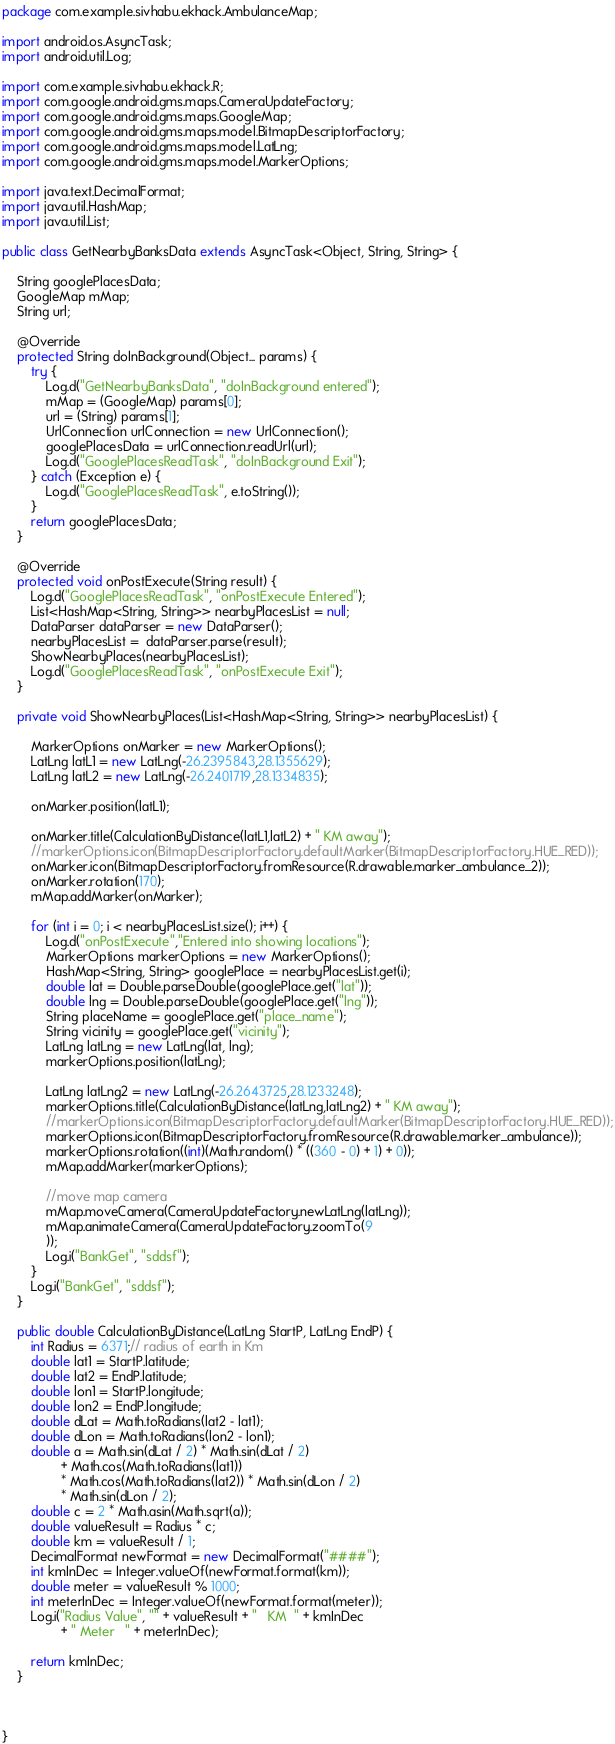<code> <loc_0><loc_0><loc_500><loc_500><_Java_>package com.example.sivhabu.ekhack.AmbulanceMap;

import android.os.AsyncTask;
import android.util.Log;

import com.example.sivhabu.ekhack.R;
import com.google.android.gms.maps.CameraUpdateFactory;
import com.google.android.gms.maps.GoogleMap;
import com.google.android.gms.maps.model.BitmapDescriptorFactory;
import com.google.android.gms.maps.model.LatLng;
import com.google.android.gms.maps.model.MarkerOptions;

import java.text.DecimalFormat;
import java.util.HashMap;
import java.util.List;

public class GetNearbyBanksData extends AsyncTask<Object, String, String> {

    String googlePlacesData;
    GoogleMap mMap;
    String url;

    @Override
    protected String doInBackground(Object... params) {
        try {
            Log.d("GetNearbyBanksData", "doInBackground entered");
            mMap = (GoogleMap) params[0];
            url = (String) params[1];
            UrlConnection urlConnection = new UrlConnection();
            googlePlacesData = urlConnection.readUrl(url);
            Log.d("GooglePlacesReadTask", "doInBackground Exit");
        } catch (Exception e) {
            Log.d("GooglePlacesReadTask", e.toString());
        }
        return googlePlacesData;
    }

    @Override
    protected void onPostExecute(String result) {
        Log.d("GooglePlacesReadTask", "onPostExecute Entered");
        List<HashMap<String, String>> nearbyPlacesList = null;
        DataParser dataParser = new DataParser();
        nearbyPlacesList =  dataParser.parse(result);
        ShowNearbyPlaces(nearbyPlacesList);
        Log.d("GooglePlacesReadTask", "onPostExecute Exit");
    }

    private void ShowNearbyPlaces(List<HashMap<String, String>> nearbyPlacesList) {

        MarkerOptions onMarker = new MarkerOptions();
        LatLng latL1 = new LatLng(-26.2395843,28.1355629);
        LatLng latL2 = new LatLng(-26.2401719,28.1334835);

        onMarker.position(latL1);

        onMarker.title(CalculationByDistance(latL1,latL2) + " KM away");
        //markerOptions.icon(BitmapDescriptorFactory.defaultMarker(BitmapDescriptorFactory.HUE_RED));
        onMarker.icon(BitmapDescriptorFactory.fromResource(R.drawable.marker_ambulance_2));
        onMarker.rotation(170);
        mMap.addMarker(onMarker);

        for (int i = 0; i < nearbyPlacesList.size(); i++) {
            Log.d("onPostExecute","Entered into showing locations");
            MarkerOptions markerOptions = new MarkerOptions();
            HashMap<String, String> googlePlace = nearbyPlacesList.get(i);
            double lat = Double.parseDouble(googlePlace.get("lat"));
            double lng = Double.parseDouble(googlePlace.get("lng"));
            String placeName = googlePlace.get("place_name");
            String vicinity = googlePlace.get("vicinity");
            LatLng latLng = new LatLng(lat, lng);
            markerOptions.position(latLng);

            LatLng latLng2 = new LatLng(-26.2643725,28.1233248);
            markerOptions.title(CalculationByDistance(latLng,latLng2) + " KM away");
            //markerOptions.icon(BitmapDescriptorFactory.defaultMarker(BitmapDescriptorFactory.HUE_RED));
            markerOptions.icon(BitmapDescriptorFactory.fromResource(R.drawable.marker_ambulance));
            markerOptions.rotation((int)(Math.random() * ((360 - 0) + 1) + 0));
            mMap.addMarker(markerOptions);

            //move map camera
            mMap.moveCamera(CameraUpdateFactory.newLatLng(latLng));
            mMap.animateCamera(CameraUpdateFactory.zoomTo(9
            ));
            Log.i("BankGet", "sddsf");
        }
        Log.i("BankGet", "sddsf");
    }

    public double CalculationByDistance(LatLng StartP, LatLng EndP) {
        int Radius = 6371;// radius of earth in Km
        double lat1 = StartP.latitude;
        double lat2 = EndP.latitude;
        double lon1 = StartP.longitude;
        double lon2 = EndP.longitude;
        double dLat = Math.toRadians(lat2 - lat1);
        double dLon = Math.toRadians(lon2 - lon1);
        double a = Math.sin(dLat / 2) * Math.sin(dLat / 2)
                + Math.cos(Math.toRadians(lat1))
                * Math.cos(Math.toRadians(lat2)) * Math.sin(dLon / 2)
                * Math.sin(dLon / 2);
        double c = 2 * Math.asin(Math.sqrt(a));
        double valueResult = Radius * c;
        double km = valueResult / 1;
        DecimalFormat newFormat = new DecimalFormat("####");
        int kmInDec = Integer.valueOf(newFormat.format(km));
        double meter = valueResult % 1000;
        int meterInDec = Integer.valueOf(newFormat.format(meter));
        Log.i("Radius Value", "" + valueResult + "   KM  " + kmInDec
                + " Meter   " + meterInDec);

        return kmInDec;
    }



}
</code> 